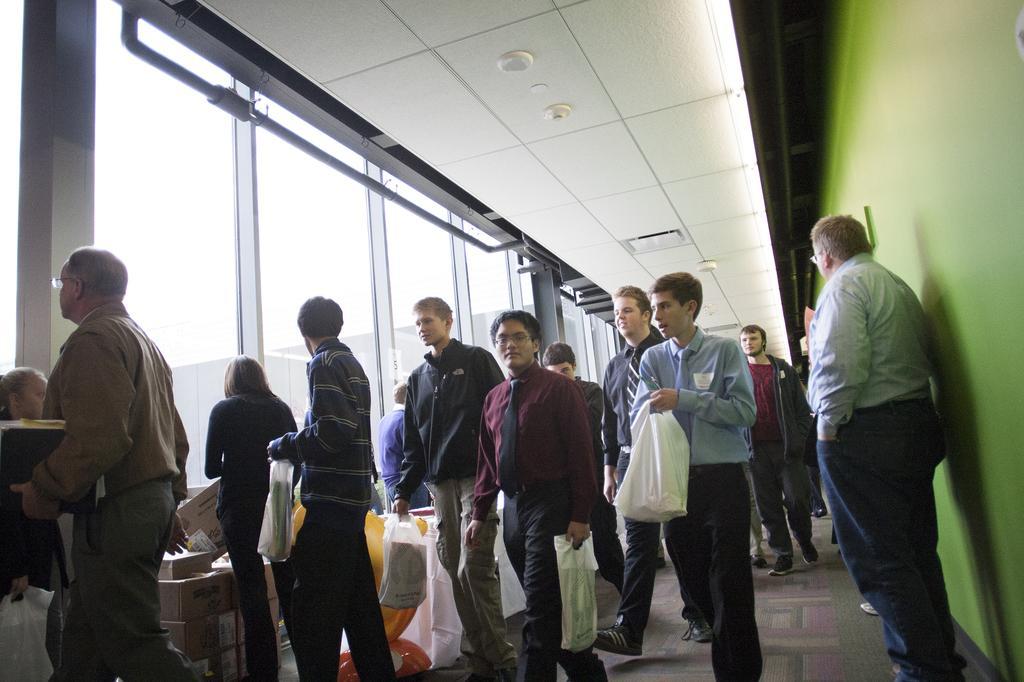How would you summarize this image in a sentence or two? In this picture I can see number of people on the floor and I see few of them are holding covers and on the right side of this image I can see the green wall. On the left side of this image I can see the glasses and on the top of this image I can see the ceiling, on which I can see the lights. 